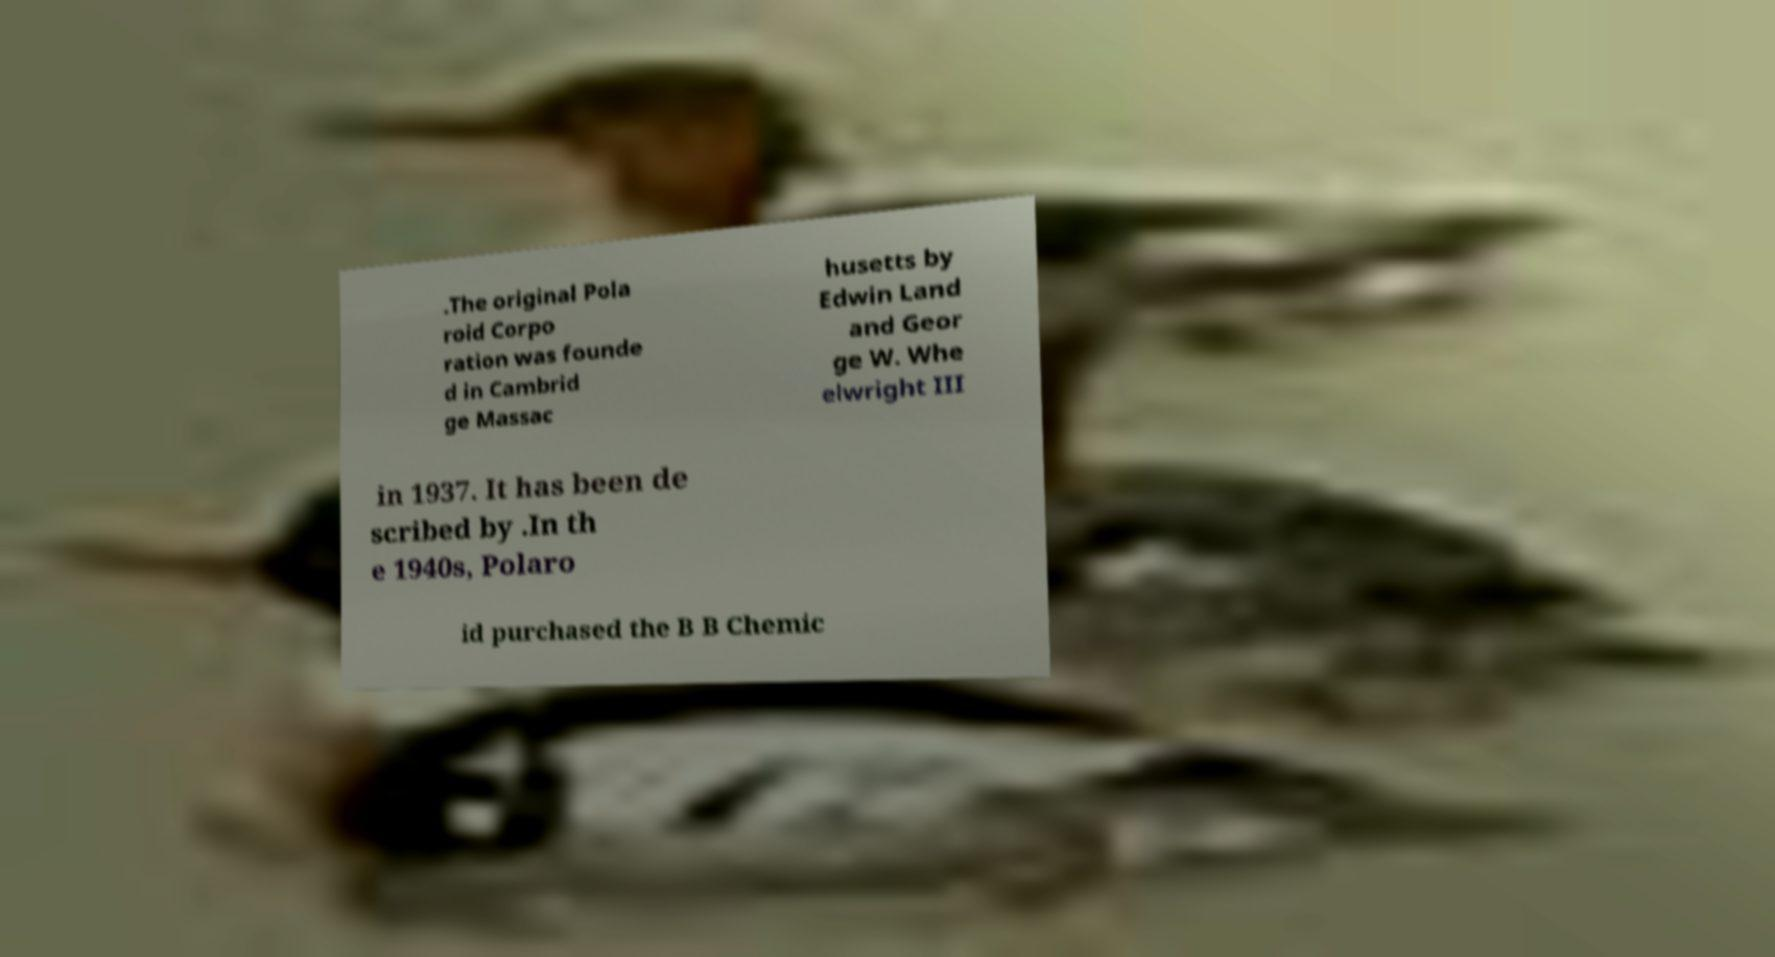For documentation purposes, I need the text within this image transcribed. Could you provide that? .The original Pola roid Corpo ration was founde d in Cambrid ge Massac husetts by Edwin Land and Geor ge W. Whe elwright III in 1937. It has been de scribed by .In th e 1940s, Polaro id purchased the B B Chemic 